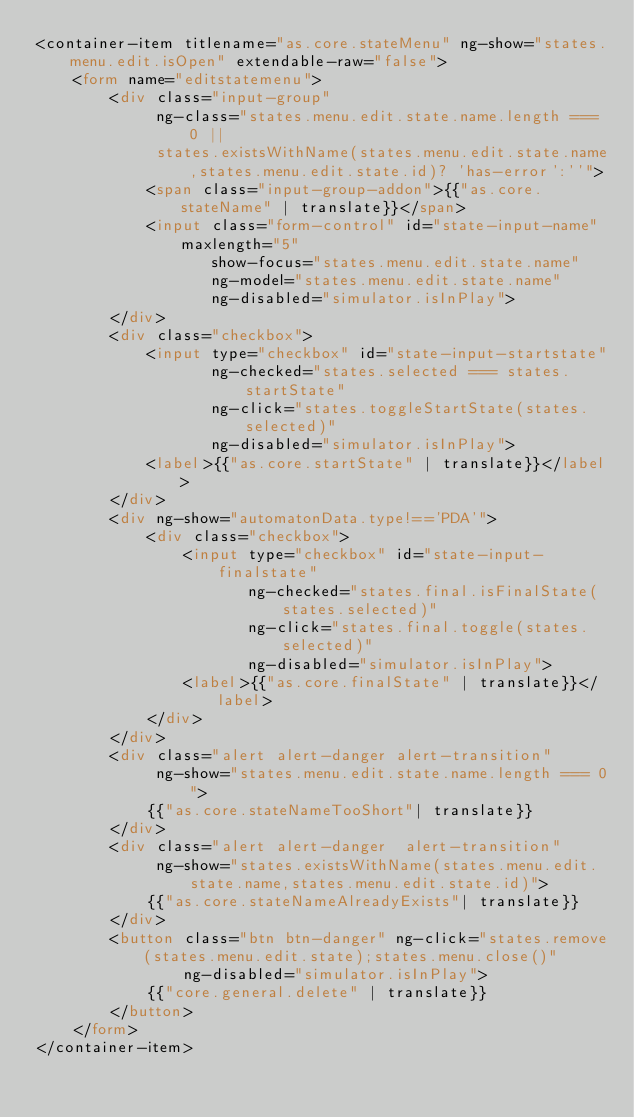Convert code to text. <code><loc_0><loc_0><loc_500><loc_500><_HTML_><container-item titlename="as.core.stateMenu" ng-show="states.menu.edit.isOpen" extendable-raw="false">
    <form name="editstatemenu">
        <div class="input-group"
             ng-class="states.menu.edit.state.name.length === 0 ||
             states.existsWithName(states.menu.edit.state.name,states.menu.edit.state.id)? 'has-error':''">
            <span class="input-group-addon">{{"as.core.stateName" | translate}}</span>
            <input class="form-control" id="state-input-name" maxlength="5"
                   show-focus="states.menu.edit.state.name"
                   ng-model="states.menu.edit.state.name"
                   ng-disabled="simulator.isInPlay">
        </div>
        <div class="checkbox">
            <input type="checkbox" id="state-input-startstate"
                   ng-checked="states.selected === states.startState"
                   ng-click="states.toggleStartState(states.selected)"
                   ng-disabled="simulator.isInPlay">
            <label>{{"as.core.startState" | translate}}</label>
        </div>
        <div ng-show="automatonData.type!=='PDA'">
            <div class="checkbox">
                <input type="checkbox" id="state-input-finalstate"
                       ng-checked="states.final.isFinalState(states.selected)"
                       ng-click="states.final.toggle(states.selected)"
                       ng-disabled="simulator.isInPlay">
                <label>{{"as.core.finalState" | translate}}</label>
            </div>
        </div>
        <div class="alert alert-danger alert-transition"
             ng-show="states.menu.edit.state.name.length === 0">
            {{"as.core.stateNameTooShort"| translate}}
        </div>
        <div class="alert alert-danger  alert-transition"
             ng-show="states.existsWithName(states.menu.edit.state.name,states.menu.edit.state.id)">
            {{"as.core.stateNameAlreadyExists"| translate}}
        </div>
        <button class="btn btn-danger" ng-click="states.remove(states.menu.edit.state);states.menu.close()"
                ng-disabled="simulator.isInPlay">
            {{"core.general.delete" | translate}}
        </button>
    </form>
</container-item></code> 